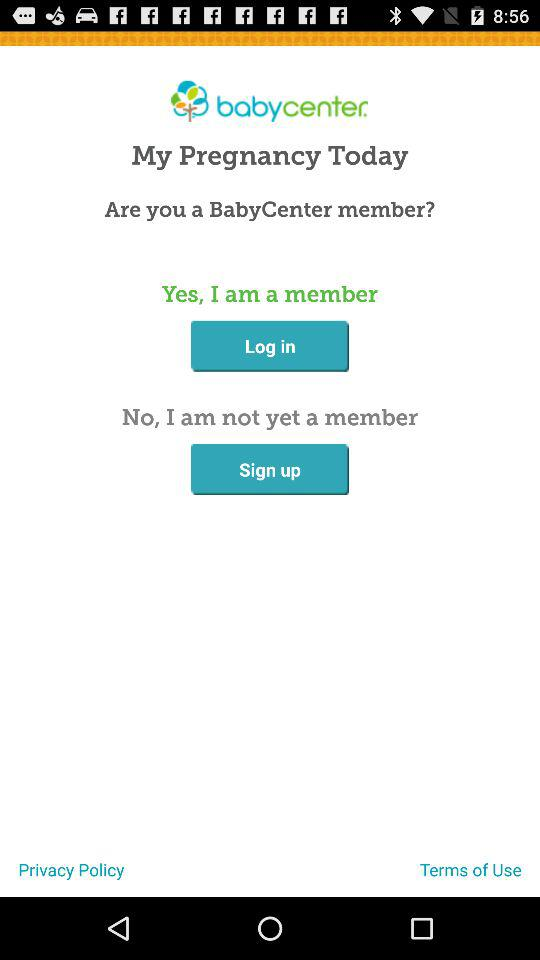What is the name of the application? The name of the application is "babycenter". 